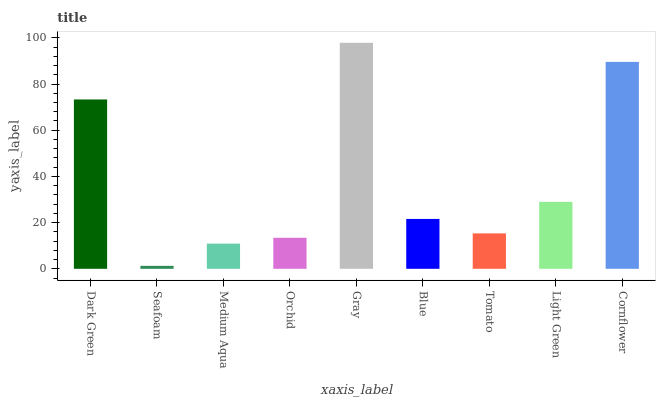Is Medium Aqua the minimum?
Answer yes or no. No. Is Medium Aqua the maximum?
Answer yes or no. No. Is Medium Aqua greater than Seafoam?
Answer yes or no. Yes. Is Seafoam less than Medium Aqua?
Answer yes or no. Yes. Is Seafoam greater than Medium Aqua?
Answer yes or no. No. Is Medium Aqua less than Seafoam?
Answer yes or no. No. Is Blue the high median?
Answer yes or no. Yes. Is Blue the low median?
Answer yes or no. Yes. Is Gray the high median?
Answer yes or no. No. Is Dark Green the low median?
Answer yes or no. No. 